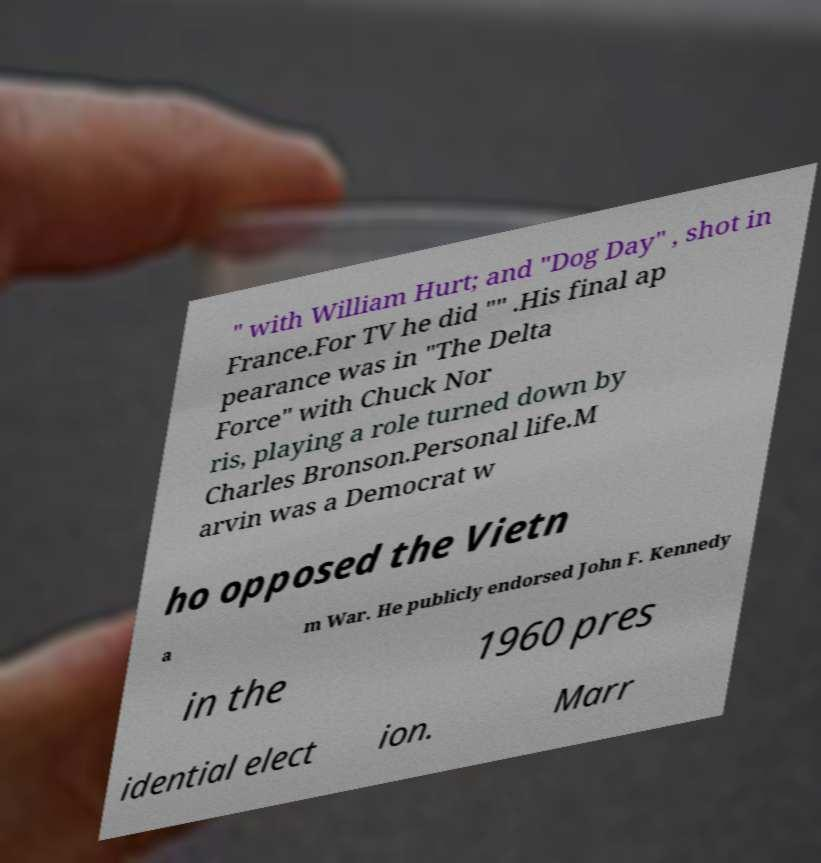Can you read and provide the text displayed in the image?This photo seems to have some interesting text. Can you extract and type it out for me? " with William Hurt; and "Dog Day" , shot in France.For TV he did "" .His final ap pearance was in "The Delta Force" with Chuck Nor ris, playing a role turned down by Charles Bronson.Personal life.M arvin was a Democrat w ho opposed the Vietn a m War. He publicly endorsed John F. Kennedy in the 1960 pres idential elect ion. Marr 